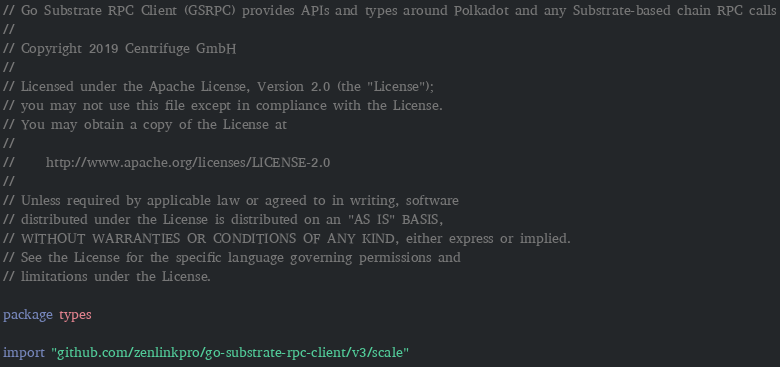Convert code to text. <code><loc_0><loc_0><loc_500><loc_500><_Go_>// Go Substrate RPC Client (GSRPC) provides APIs and types around Polkadot and any Substrate-based chain RPC calls
//
// Copyright 2019 Centrifuge GmbH
//
// Licensed under the Apache License, Version 2.0 (the "License");
// you may not use this file except in compliance with the License.
// You may obtain a copy of the License at
//
//     http://www.apache.org/licenses/LICENSE-2.0
//
// Unless required by applicable law or agreed to in writing, software
// distributed under the License is distributed on an "AS IS" BASIS,
// WITHOUT WARRANTIES OR CONDITIONS OF ANY KIND, either express or implied.
// See the License for the specific language governing permissions and
// limitations under the License.

package types

import "github.com/zenlinkpro/go-substrate-rpc-client/v3/scale"
</code> 